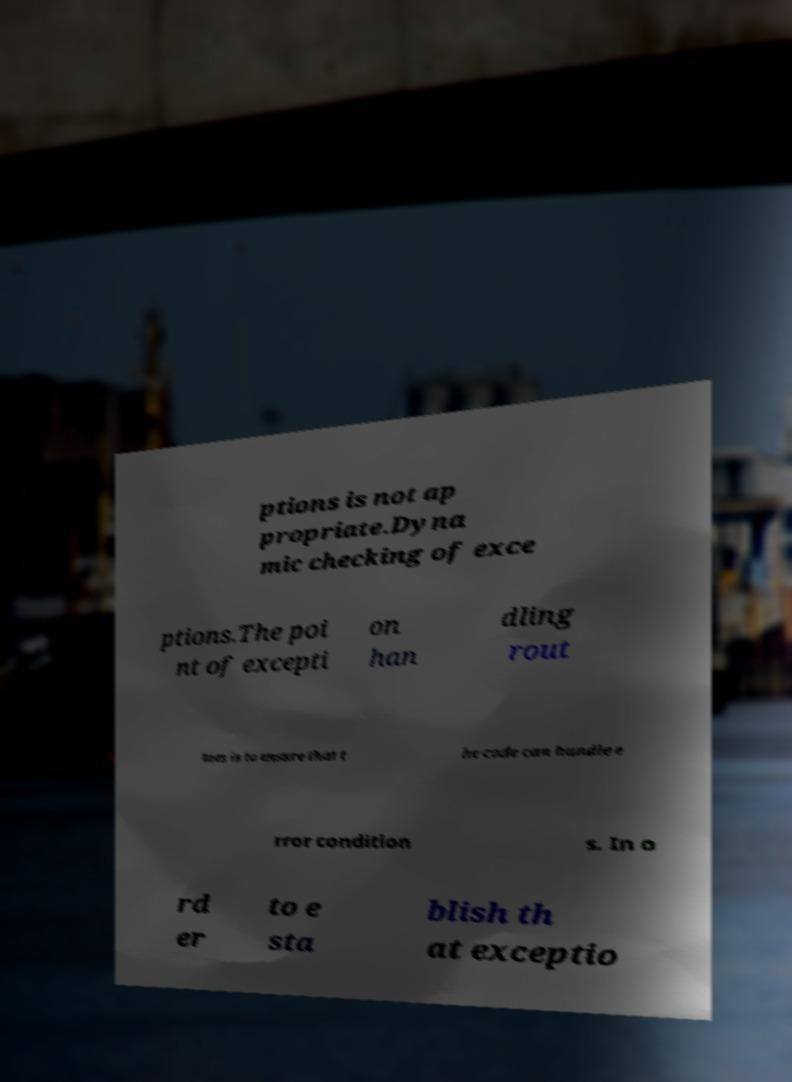Please read and relay the text visible in this image. What does it say? ptions is not ap propriate.Dyna mic checking of exce ptions.The poi nt of excepti on han dling rout ines is to ensure that t he code can handle e rror condition s. In o rd er to e sta blish th at exceptio 